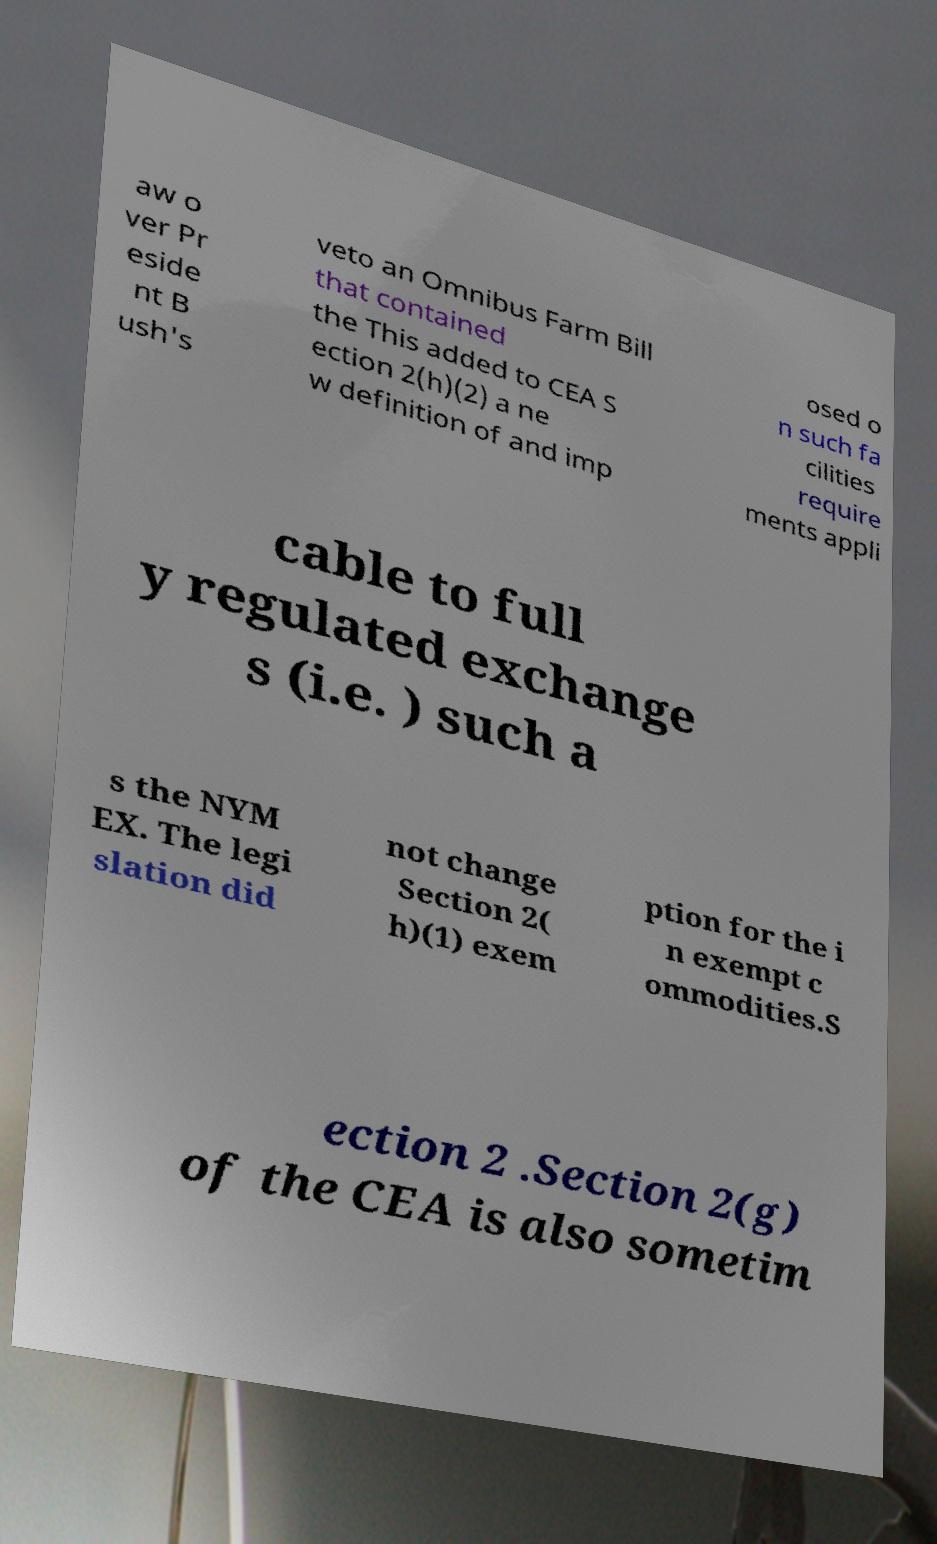Could you extract and type out the text from this image? aw o ver Pr eside nt B ush's veto an Omnibus Farm Bill that contained the This added to CEA S ection 2(h)(2) a ne w definition of and imp osed o n such fa cilities require ments appli cable to full y regulated exchange s (i.e. ) such a s the NYM EX. The legi slation did not change Section 2( h)(1) exem ption for the i n exempt c ommodities.S ection 2 .Section 2(g) of the CEA is also sometim 